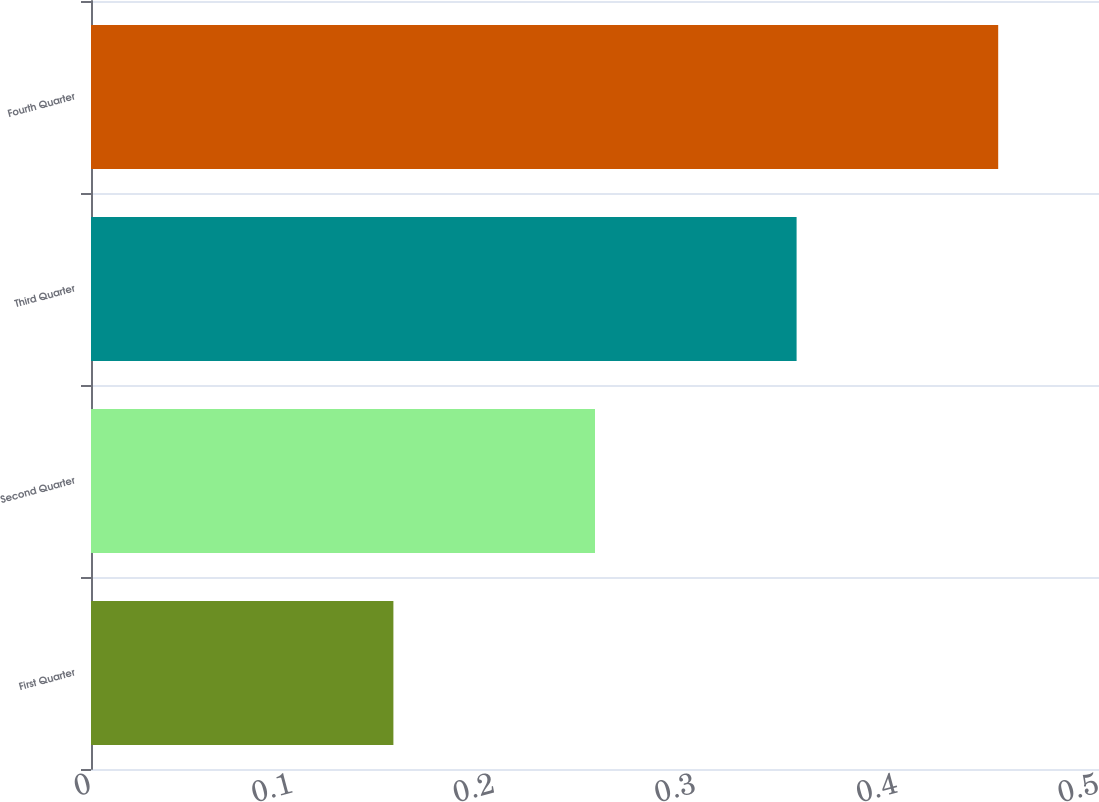Convert chart. <chart><loc_0><loc_0><loc_500><loc_500><bar_chart><fcel>First Quarter<fcel>Second Quarter<fcel>Third Quarter<fcel>Fourth Quarter<nl><fcel>0.15<fcel>0.25<fcel>0.35<fcel>0.45<nl></chart> 